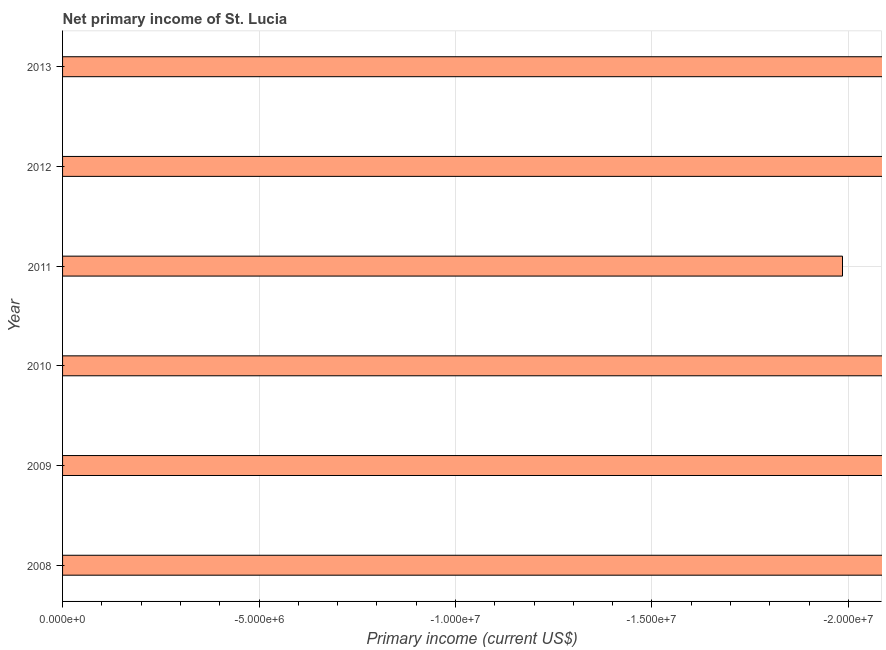Does the graph contain any zero values?
Offer a terse response. Yes. Does the graph contain grids?
Ensure brevity in your answer.  Yes. What is the title of the graph?
Make the answer very short. Net primary income of St. Lucia. What is the label or title of the X-axis?
Provide a short and direct response. Primary income (current US$). Across all years, what is the minimum amount of primary income?
Your response must be concise. 0. What is the sum of the amount of primary income?
Your response must be concise. 0. What is the median amount of primary income?
Your answer should be compact. 0. In how many years, is the amount of primary income greater than the average amount of primary income taken over all years?
Your answer should be very brief. 0. Are all the bars in the graph horizontal?
Your response must be concise. Yes. What is the difference between two consecutive major ticks on the X-axis?
Make the answer very short. 5.00e+06. Are the values on the major ticks of X-axis written in scientific E-notation?
Make the answer very short. Yes. What is the Primary income (current US$) in 2009?
Your answer should be very brief. 0. What is the Primary income (current US$) of 2012?
Offer a very short reply. 0. What is the Primary income (current US$) in 2013?
Offer a very short reply. 0. 